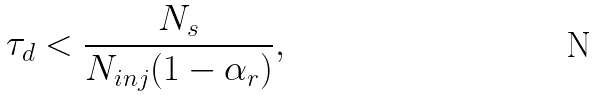Convert formula to latex. <formula><loc_0><loc_0><loc_500><loc_500>\tau _ { d } < \frac { N _ { s } } { N _ { i n j } ( 1 - \alpha _ { r } ) } ,</formula> 